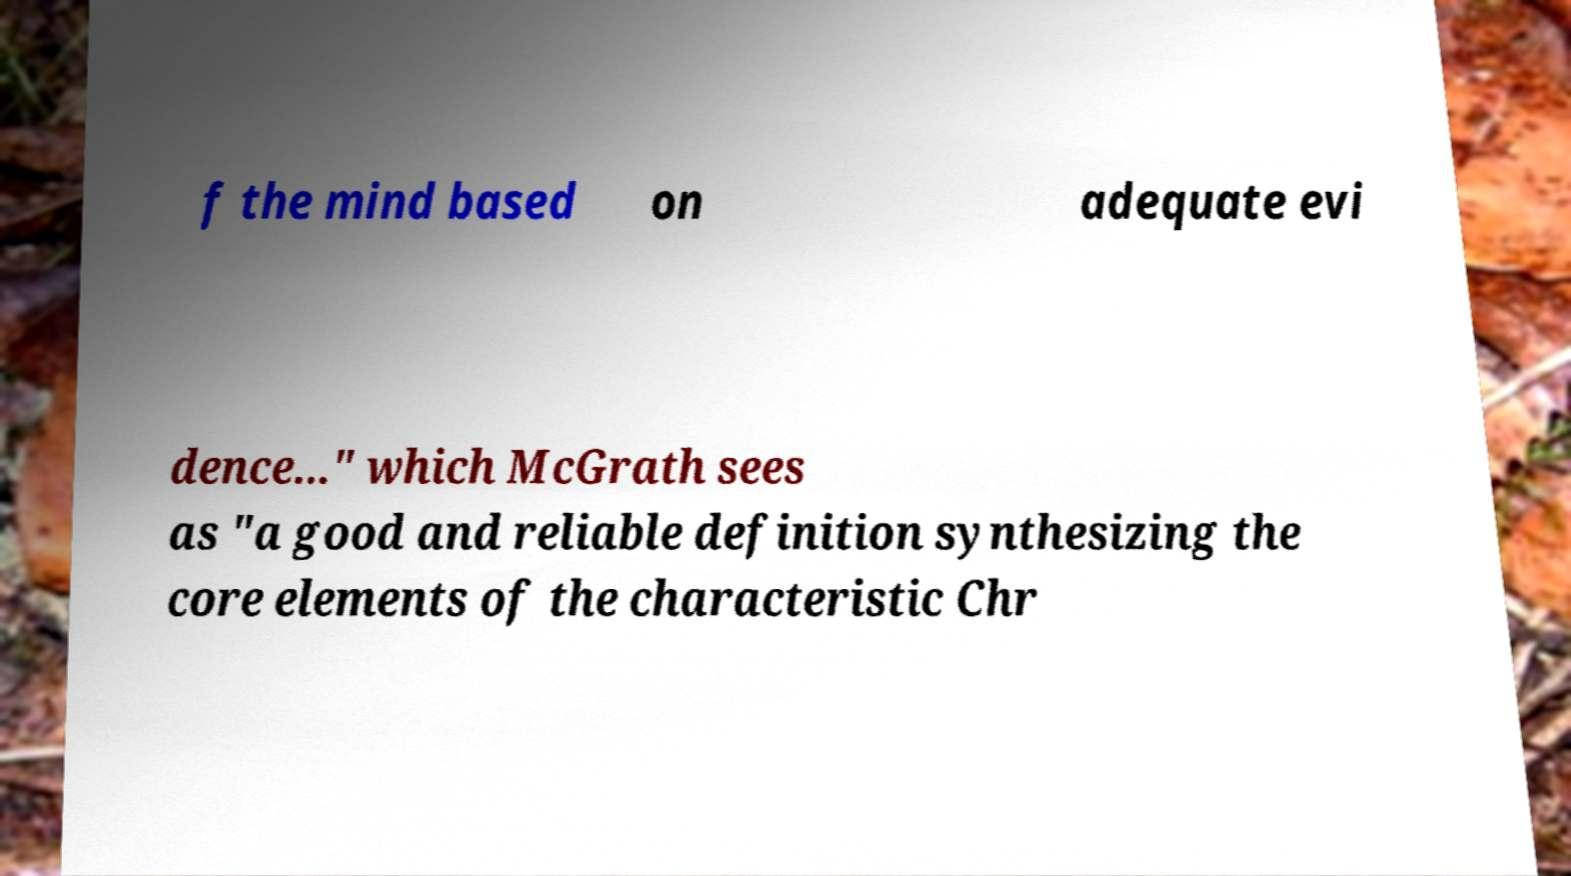Please read and relay the text visible in this image. What does it say? f the mind based on adequate evi dence..." which McGrath sees as "a good and reliable definition synthesizing the core elements of the characteristic Chr 